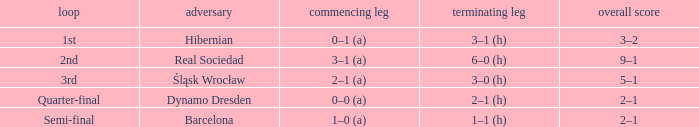Who were the opposition in the quarter-final? Dynamo Dresden. 